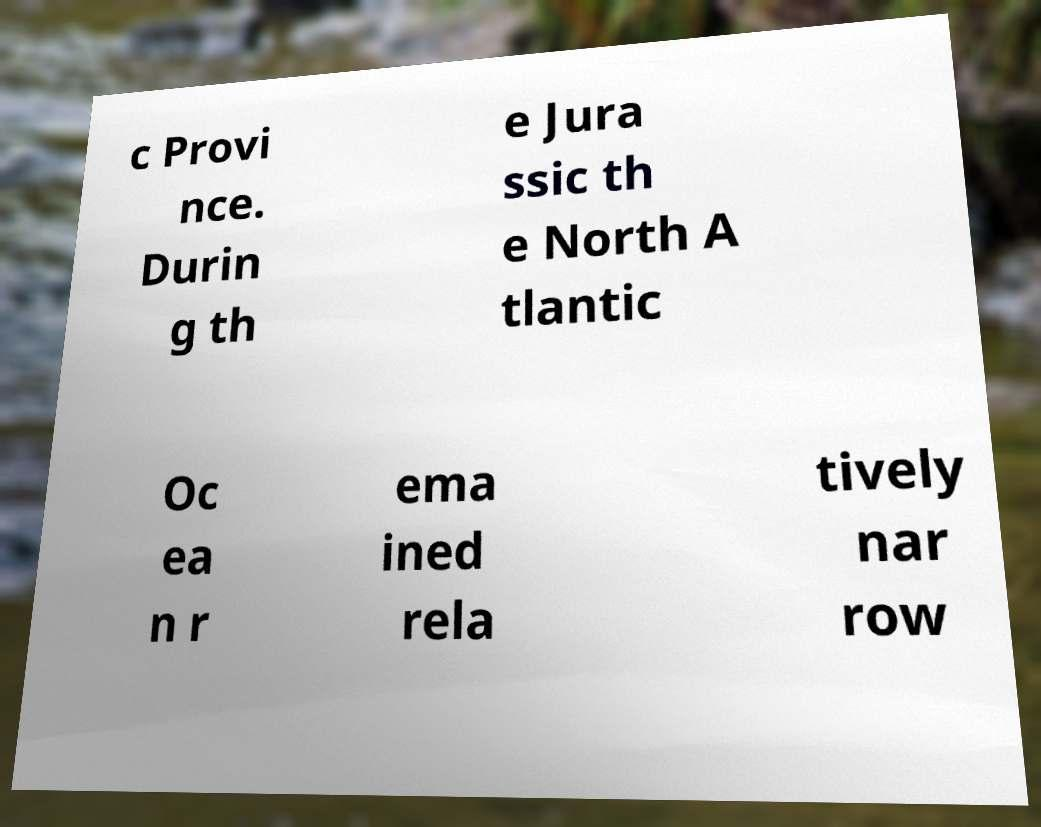What messages or text are displayed in this image? I need them in a readable, typed format. c Provi nce. Durin g th e Jura ssic th e North A tlantic Oc ea n r ema ined rela tively nar row 